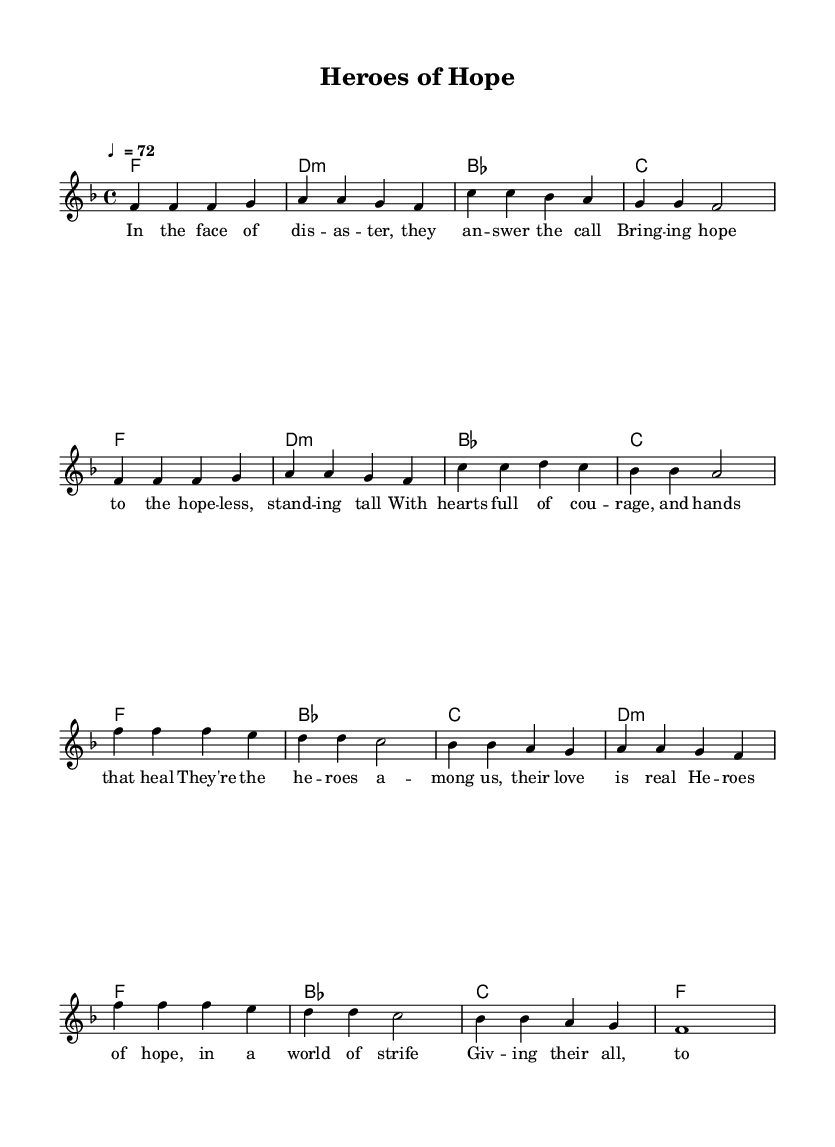What is the key signature of this music? The key signature is F major, which has one flat (B flat). This can be determined by looking for the key signature indication at the beginning of the staff where it shows that one note, B, is lowered.
Answer: F major What is the time signature of this music? The time signature is 4/4, which is indicated at the beginning of the score. It signifies that there are four beats in each measure and a quarter note receives one beat.
Answer: 4/4 What is the tempo marking of this music? The tempo marking is indicated as "♩ = 72," which shows the speed of the piece, specifying that there are 72 beats per minute.
Answer: 72 How many measures are in the verse section? The verse section consists of 8 measures, as observed in the notation where the melody and harmonies are laid out sequentially, showing two sets of four measures.
Answer: 8 measures What is the chord progression for the chorus? The chord progression for the chorus is F, B flat, C, D minor, repeating in the same order. This can be identified by looking at the harmonies written above the melody notes during the chorus.
Answer: F, B flat, C, D minor What theme does the chorus emphasize in relation to humanitarian work? The chorus emphasizes hope and dedication in aiding others, as reflected in lyrics that highlight the bravery and contribution of volunteers and workers. This thematic exploration is apparent in the words of the chorus.
Answer: Hope and dedication 